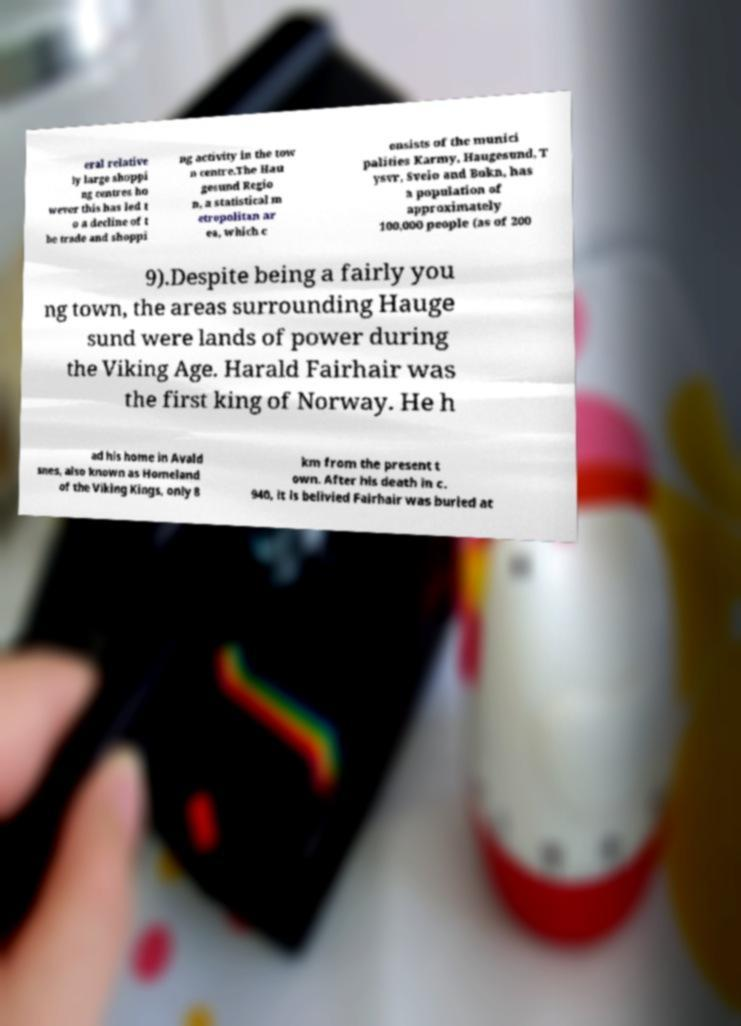There's text embedded in this image that I need extracted. Can you transcribe it verbatim? eral relative ly large shoppi ng centres ho wever this has led t o a decline of t he trade and shoppi ng activity in the tow n centre.The Hau gesund Regio n, a statistical m etropolitan ar ea, which c onsists of the munici palities Karmy, Haugesund, T ysvr, Sveio and Bokn, has a population of approximately 100,000 people (as of 200 9).Despite being a fairly you ng town, the areas surrounding Hauge sund were lands of power during the Viking Age. Harald Fairhair was the first king of Norway. He h ad his home in Avald snes, also known as Homeland of the Viking Kings, only 8 km from the present t own. After his death in c. 940, it is belivied Fairhair was buried at 